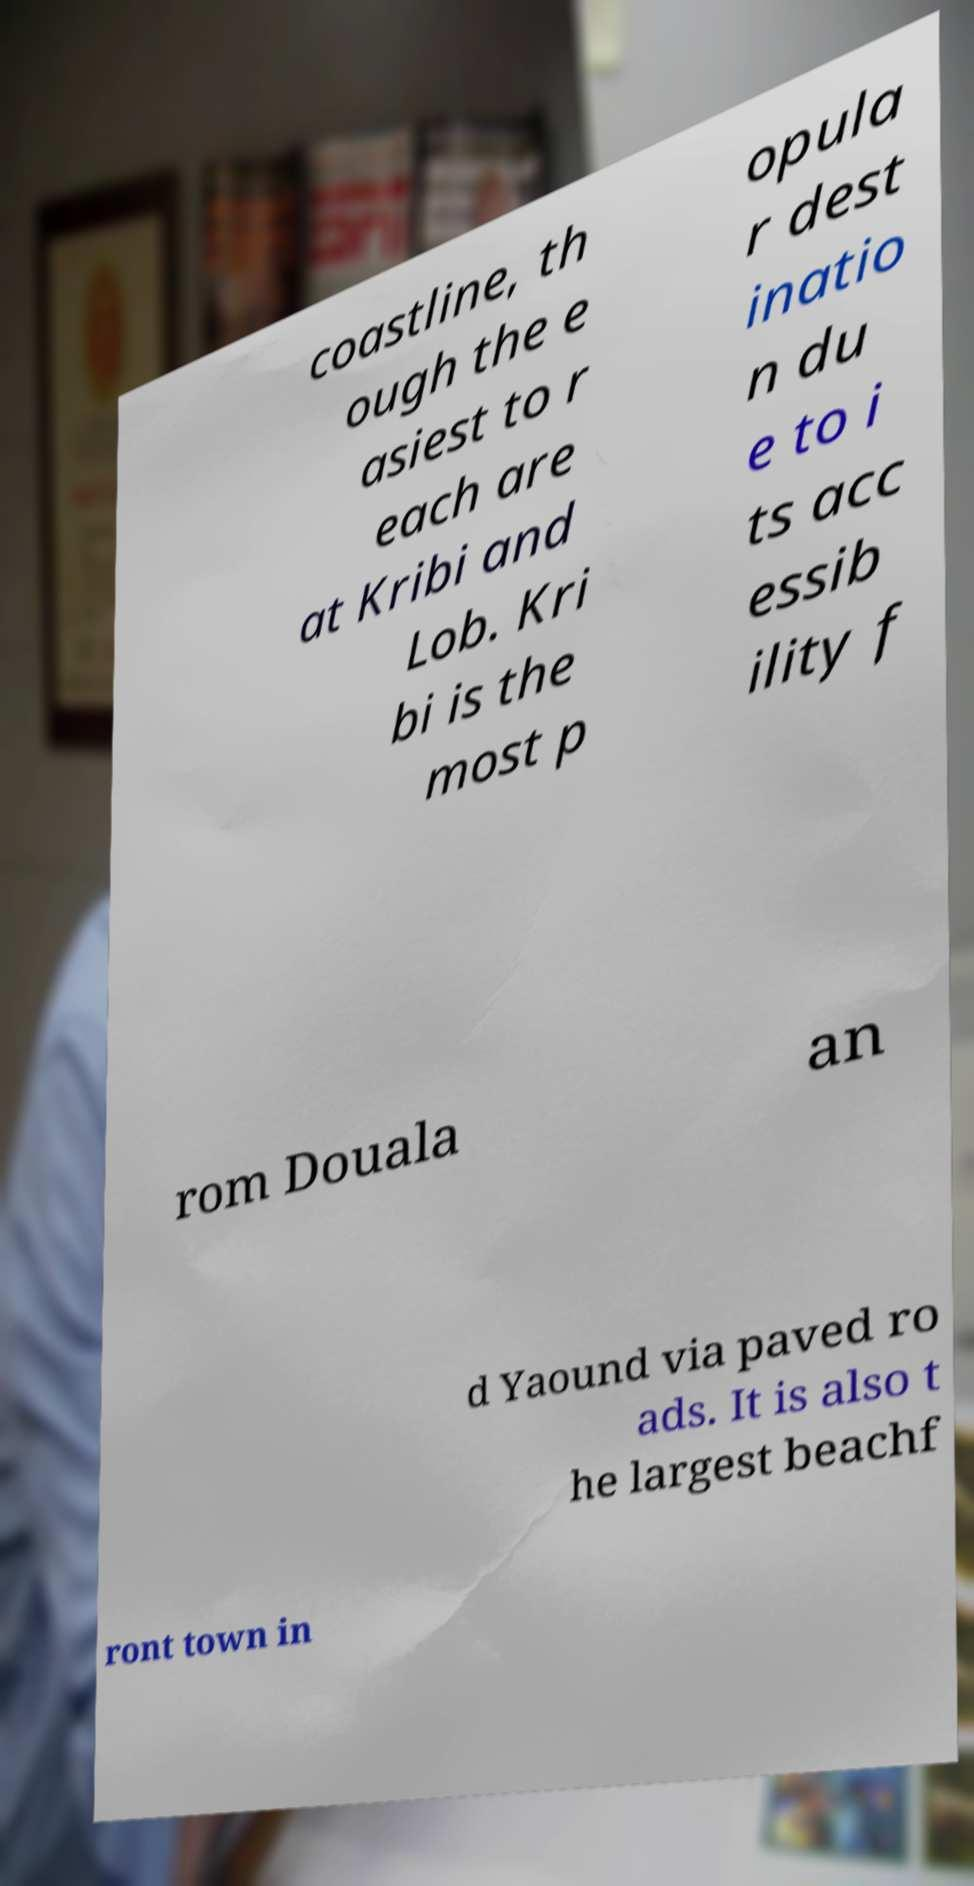For documentation purposes, I need the text within this image transcribed. Could you provide that? coastline, th ough the e asiest to r each are at Kribi and Lob. Kri bi is the most p opula r dest inatio n du e to i ts acc essib ility f rom Douala an d Yaound via paved ro ads. It is also t he largest beachf ront town in 